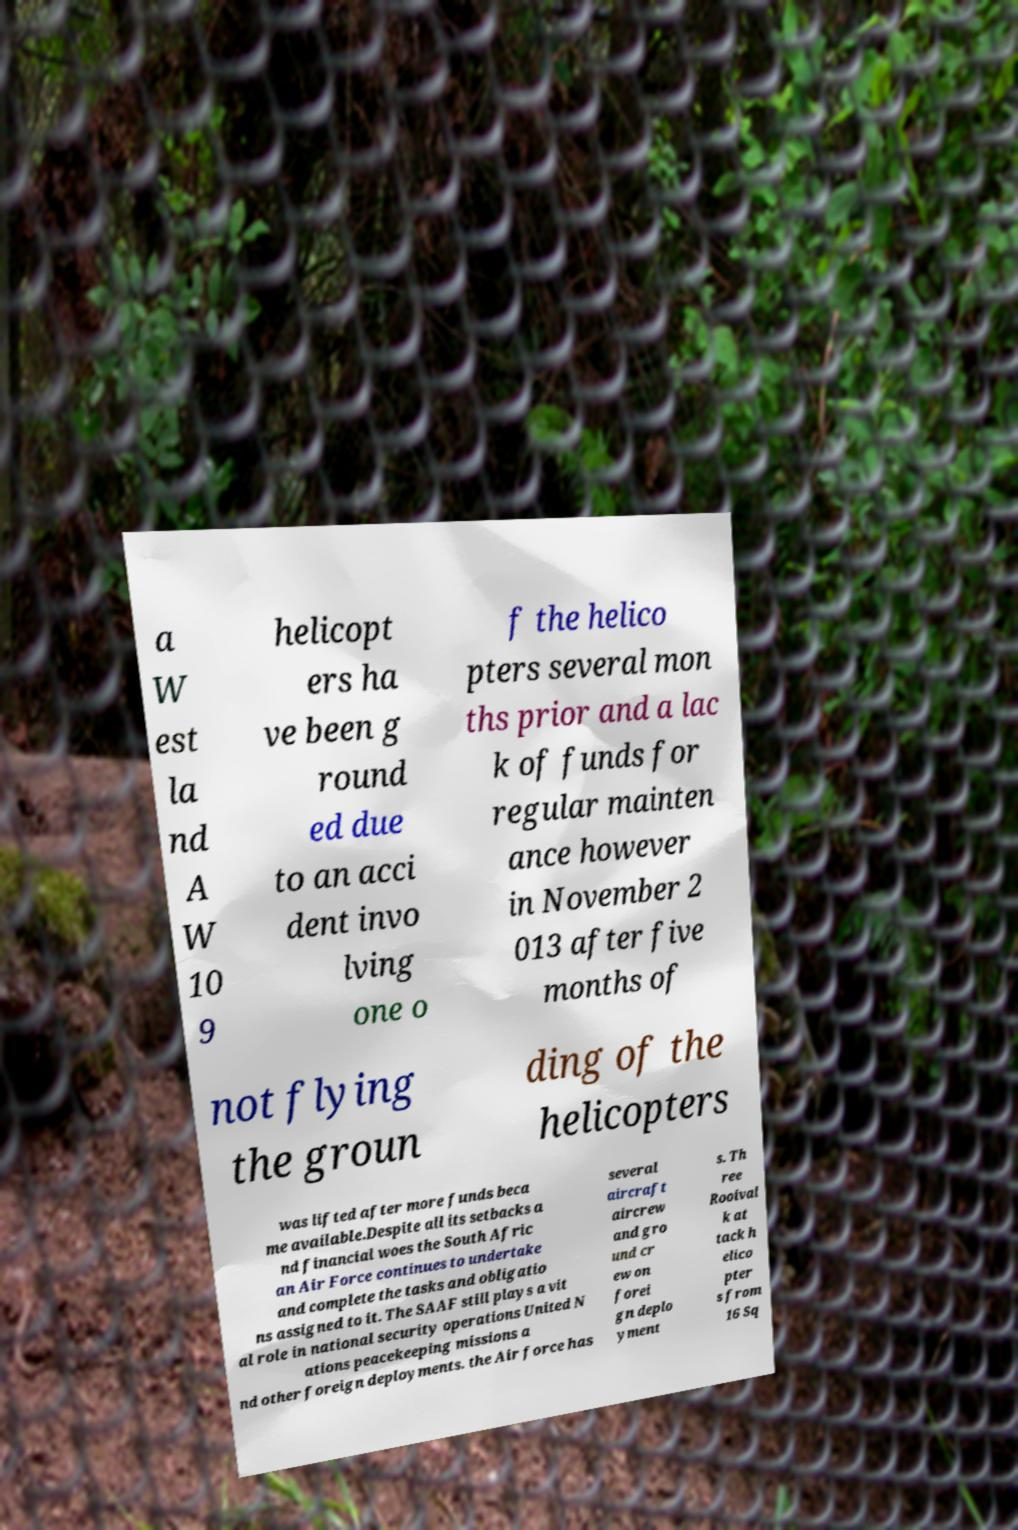Could you assist in decoding the text presented in this image and type it out clearly? a W est la nd A W 10 9 helicopt ers ha ve been g round ed due to an acci dent invo lving one o f the helico pters several mon ths prior and a lac k of funds for regular mainten ance however in November 2 013 after five months of not flying the groun ding of the helicopters was lifted after more funds beca me available.Despite all its setbacks a nd financial woes the South Afric an Air Force continues to undertake and complete the tasks and obligatio ns assigned to it. The SAAF still plays a vit al role in national security operations United N ations peacekeeping missions a nd other foreign deployments. the Air force has several aircraft aircrew and gro und cr ew on forei gn deplo yment s. Th ree Rooival k at tack h elico pter s from 16 Sq 